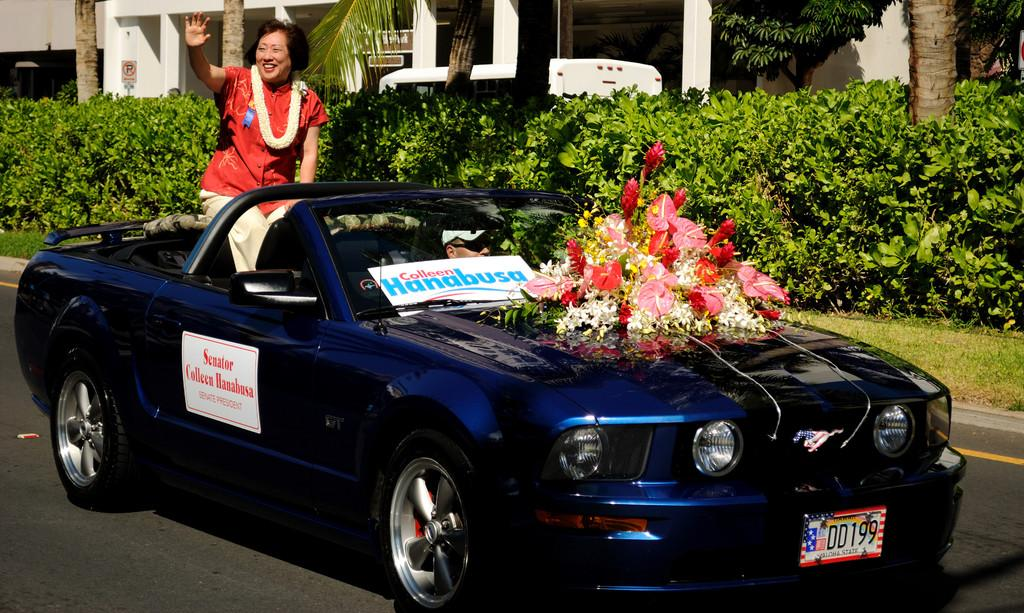What is the woman in the image doing? The woman is waving in the image. Where is the woman sitting? The woman is sitting on a car. What color is the car? The car is blue. What can be seen on the hood of the car? There is a flower bouquet on the hood of the car. What is visible in the background of the image? There are plants in the background of the image. How does the woman twist the car's steering wheel in the image? The woman is not shown driving or controlling the car in the image, so there is no indication of her twisting the steering wheel. 